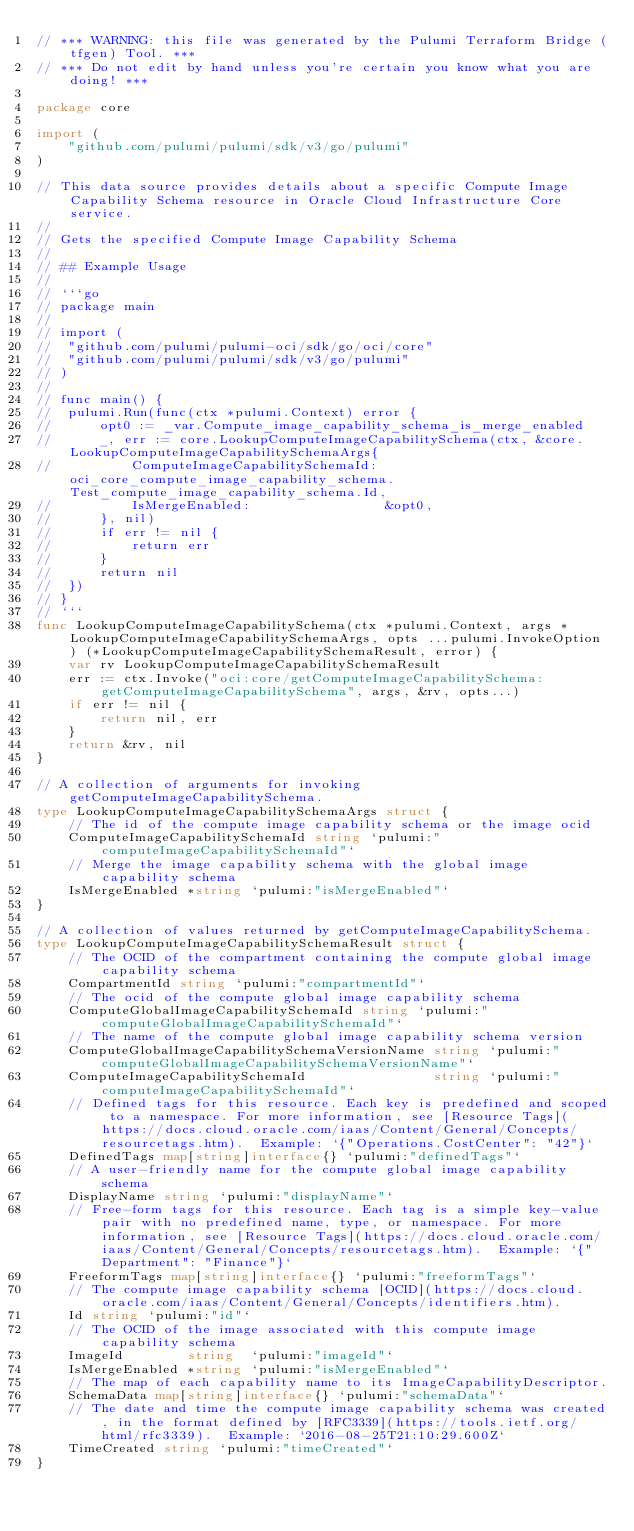Convert code to text. <code><loc_0><loc_0><loc_500><loc_500><_Go_>// *** WARNING: this file was generated by the Pulumi Terraform Bridge (tfgen) Tool. ***
// *** Do not edit by hand unless you're certain you know what you are doing! ***

package core

import (
	"github.com/pulumi/pulumi/sdk/v3/go/pulumi"
)

// This data source provides details about a specific Compute Image Capability Schema resource in Oracle Cloud Infrastructure Core service.
//
// Gets the specified Compute Image Capability Schema
//
// ## Example Usage
//
// ```go
// package main
//
// import (
// 	"github.com/pulumi/pulumi-oci/sdk/go/oci/core"
// 	"github.com/pulumi/pulumi/sdk/v3/go/pulumi"
// )
//
// func main() {
// 	pulumi.Run(func(ctx *pulumi.Context) error {
// 		opt0 := _var.Compute_image_capability_schema_is_merge_enabled
// 		_, err := core.LookupComputeImageCapabilitySchema(ctx, &core.LookupComputeImageCapabilitySchemaArgs{
// 			ComputeImageCapabilitySchemaId: oci_core_compute_image_capability_schema.Test_compute_image_capability_schema.Id,
// 			IsMergeEnabled:                 &opt0,
// 		}, nil)
// 		if err != nil {
// 			return err
// 		}
// 		return nil
// 	})
// }
// ```
func LookupComputeImageCapabilitySchema(ctx *pulumi.Context, args *LookupComputeImageCapabilitySchemaArgs, opts ...pulumi.InvokeOption) (*LookupComputeImageCapabilitySchemaResult, error) {
	var rv LookupComputeImageCapabilitySchemaResult
	err := ctx.Invoke("oci:core/getComputeImageCapabilitySchema:getComputeImageCapabilitySchema", args, &rv, opts...)
	if err != nil {
		return nil, err
	}
	return &rv, nil
}

// A collection of arguments for invoking getComputeImageCapabilitySchema.
type LookupComputeImageCapabilitySchemaArgs struct {
	// The id of the compute image capability schema or the image ocid
	ComputeImageCapabilitySchemaId string `pulumi:"computeImageCapabilitySchemaId"`
	// Merge the image capability schema with the global image capability schema
	IsMergeEnabled *string `pulumi:"isMergeEnabled"`
}

// A collection of values returned by getComputeImageCapabilitySchema.
type LookupComputeImageCapabilitySchemaResult struct {
	// The OCID of the compartment containing the compute global image capability schema
	CompartmentId string `pulumi:"compartmentId"`
	// The ocid of the compute global image capability schema
	ComputeGlobalImageCapabilitySchemaId string `pulumi:"computeGlobalImageCapabilitySchemaId"`
	// The name of the compute global image capability schema version
	ComputeGlobalImageCapabilitySchemaVersionName string `pulumi:"computeGlobalImageCapabilitySchemaVersionName"`
	ComputeImageCapabilitySchemaId                string `pulumi:"computeImageCapabilitySchemaId"`
	// Defined tags for this resource. Each key is predefined and scoped to a namespace. For more information, see [Resource Tags](https://docs.cloud.oracle.com/iaas/Content/General/Concepts/resourcetags.htm).  Example: `{"Operations.CostCenter": "42"}`
	DefinedTags map[string]interface{} `pulumi:"definedTags"`
	// A user-friendly name for the compute global image capability schema
	DisplayName string `pulumi:"displayName"`
	// Free-form tags for this resource. Each tag is a simple key-value pair with no predefined name, type, or namespace. For more information, see [Resource Tags](https://docs.cloud.oracle.com/iaas/Content/General/Concepts/resourcetags.htm).  Example: `{"Department": "Finance"}`
	FreeformTags map[string]interface{} `pulumi:"freeformTags"`
	// The compute image capability schema [OCID](https://docs.cloud.oracle.com/iaas/Content/General/Concepts/identifiers.htm).
	Id string `pulumi:"id"`
	// The OCID of the image associated with this compute image capability schema
	ImageId        string  `pulumi:"imageId"`
	IsMergeEnabled *string `pulumi:"isMergeEnabled"`
	// The map of each capability name to its ImageCapabilityDescriptor.
	SchemaData map[string]interface{} `pulumi:"schemaData"`
	// The date and time the compute image capability schema was created, in the format defined by [RFC3339](https://tools.ietf.org/html/rfc3339).  Example: `2016-08-25T21:10:29.600Z`
	TimeCreated string `pulumi:"timeCreated"`
}
</code> 